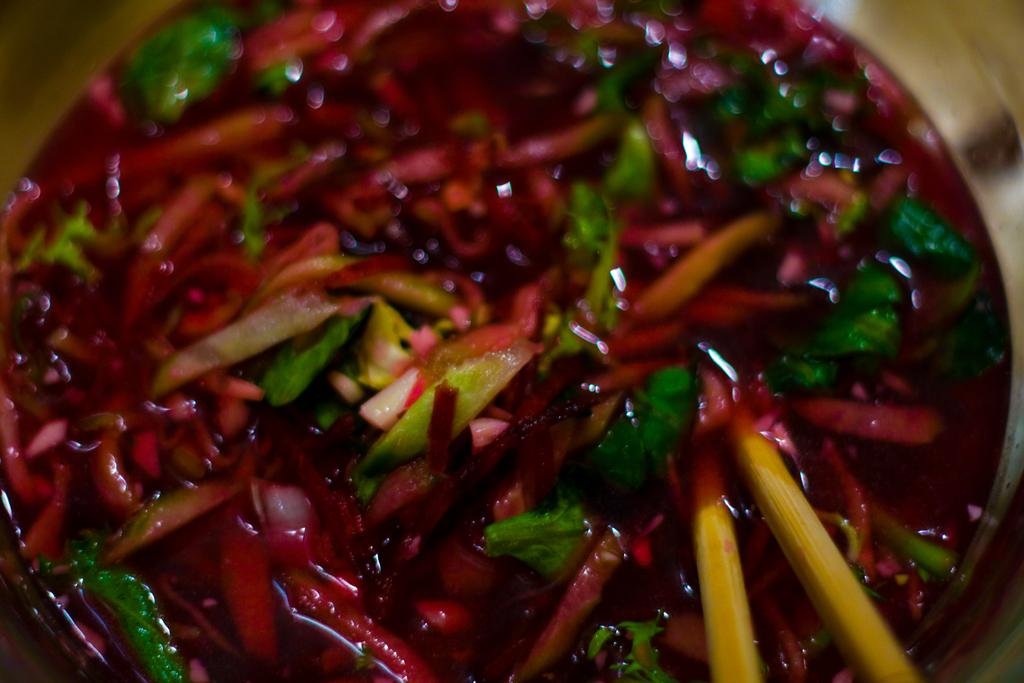What is present in the image? There is a bowl in the image. What is inside the bowl? There is a food item in the bowl. Is there a crib visible in the image? No, there is no crib present in the image. Are there any visitors in the image? No, there is no indication of any visitors in the image. What religion is being practiced in the image? There is no information about any religious practices in the image. 